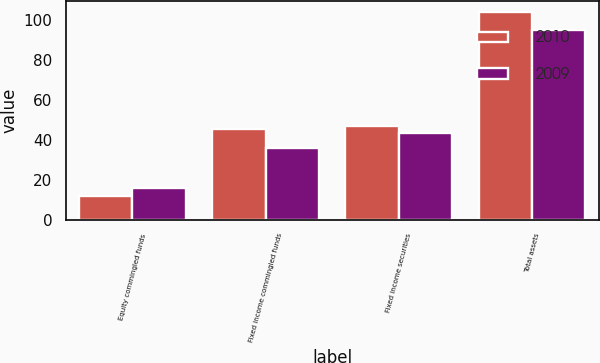Convert chart. <chart><loc_0><loc_0><loc_500><loc_500><stacked_bar_chart><ecel><fcel>Equity commingled funds<fcel>Fixed income commingled funds<fcel>Fixed income securities<fcel>Total assets<nl><fcel>2010<fcel>11.7<fcel>45.6<fcel>47.1<fcel>104.4<nl><fcel>2009<fcel>15.8<fcel>35.9<fcel>43.5<fcel>95.2<nl></chart> 